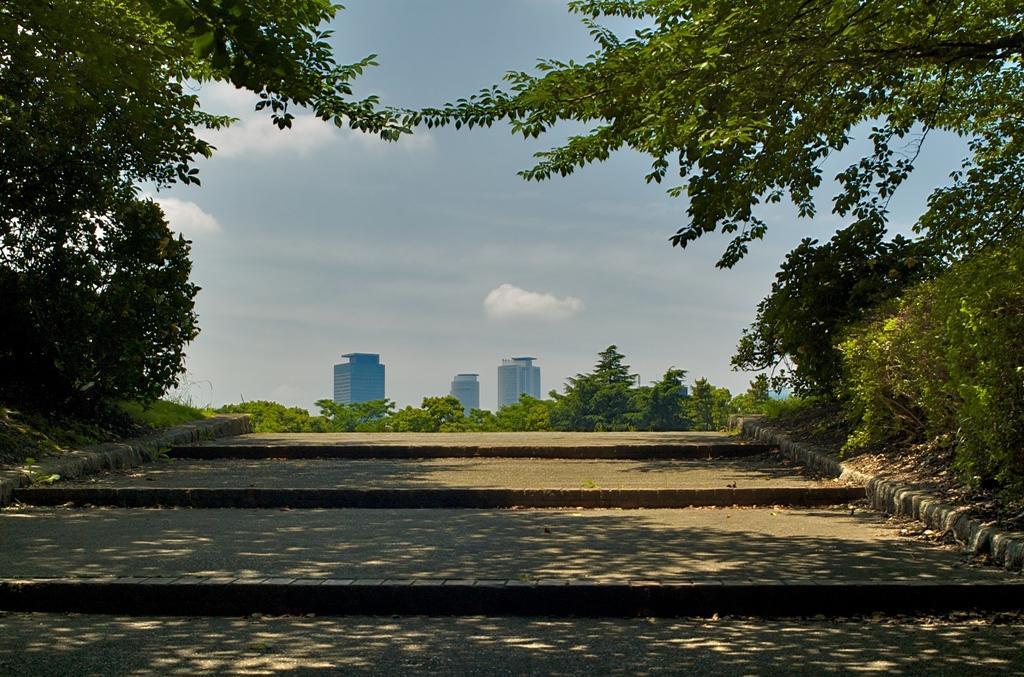How would you summarize this image in a sentence or two? In this image I can see a path in the centre. On the left side, on the right side and in the background I can see number of trees. I can also see few buildings, clouds and the sky in the background. 